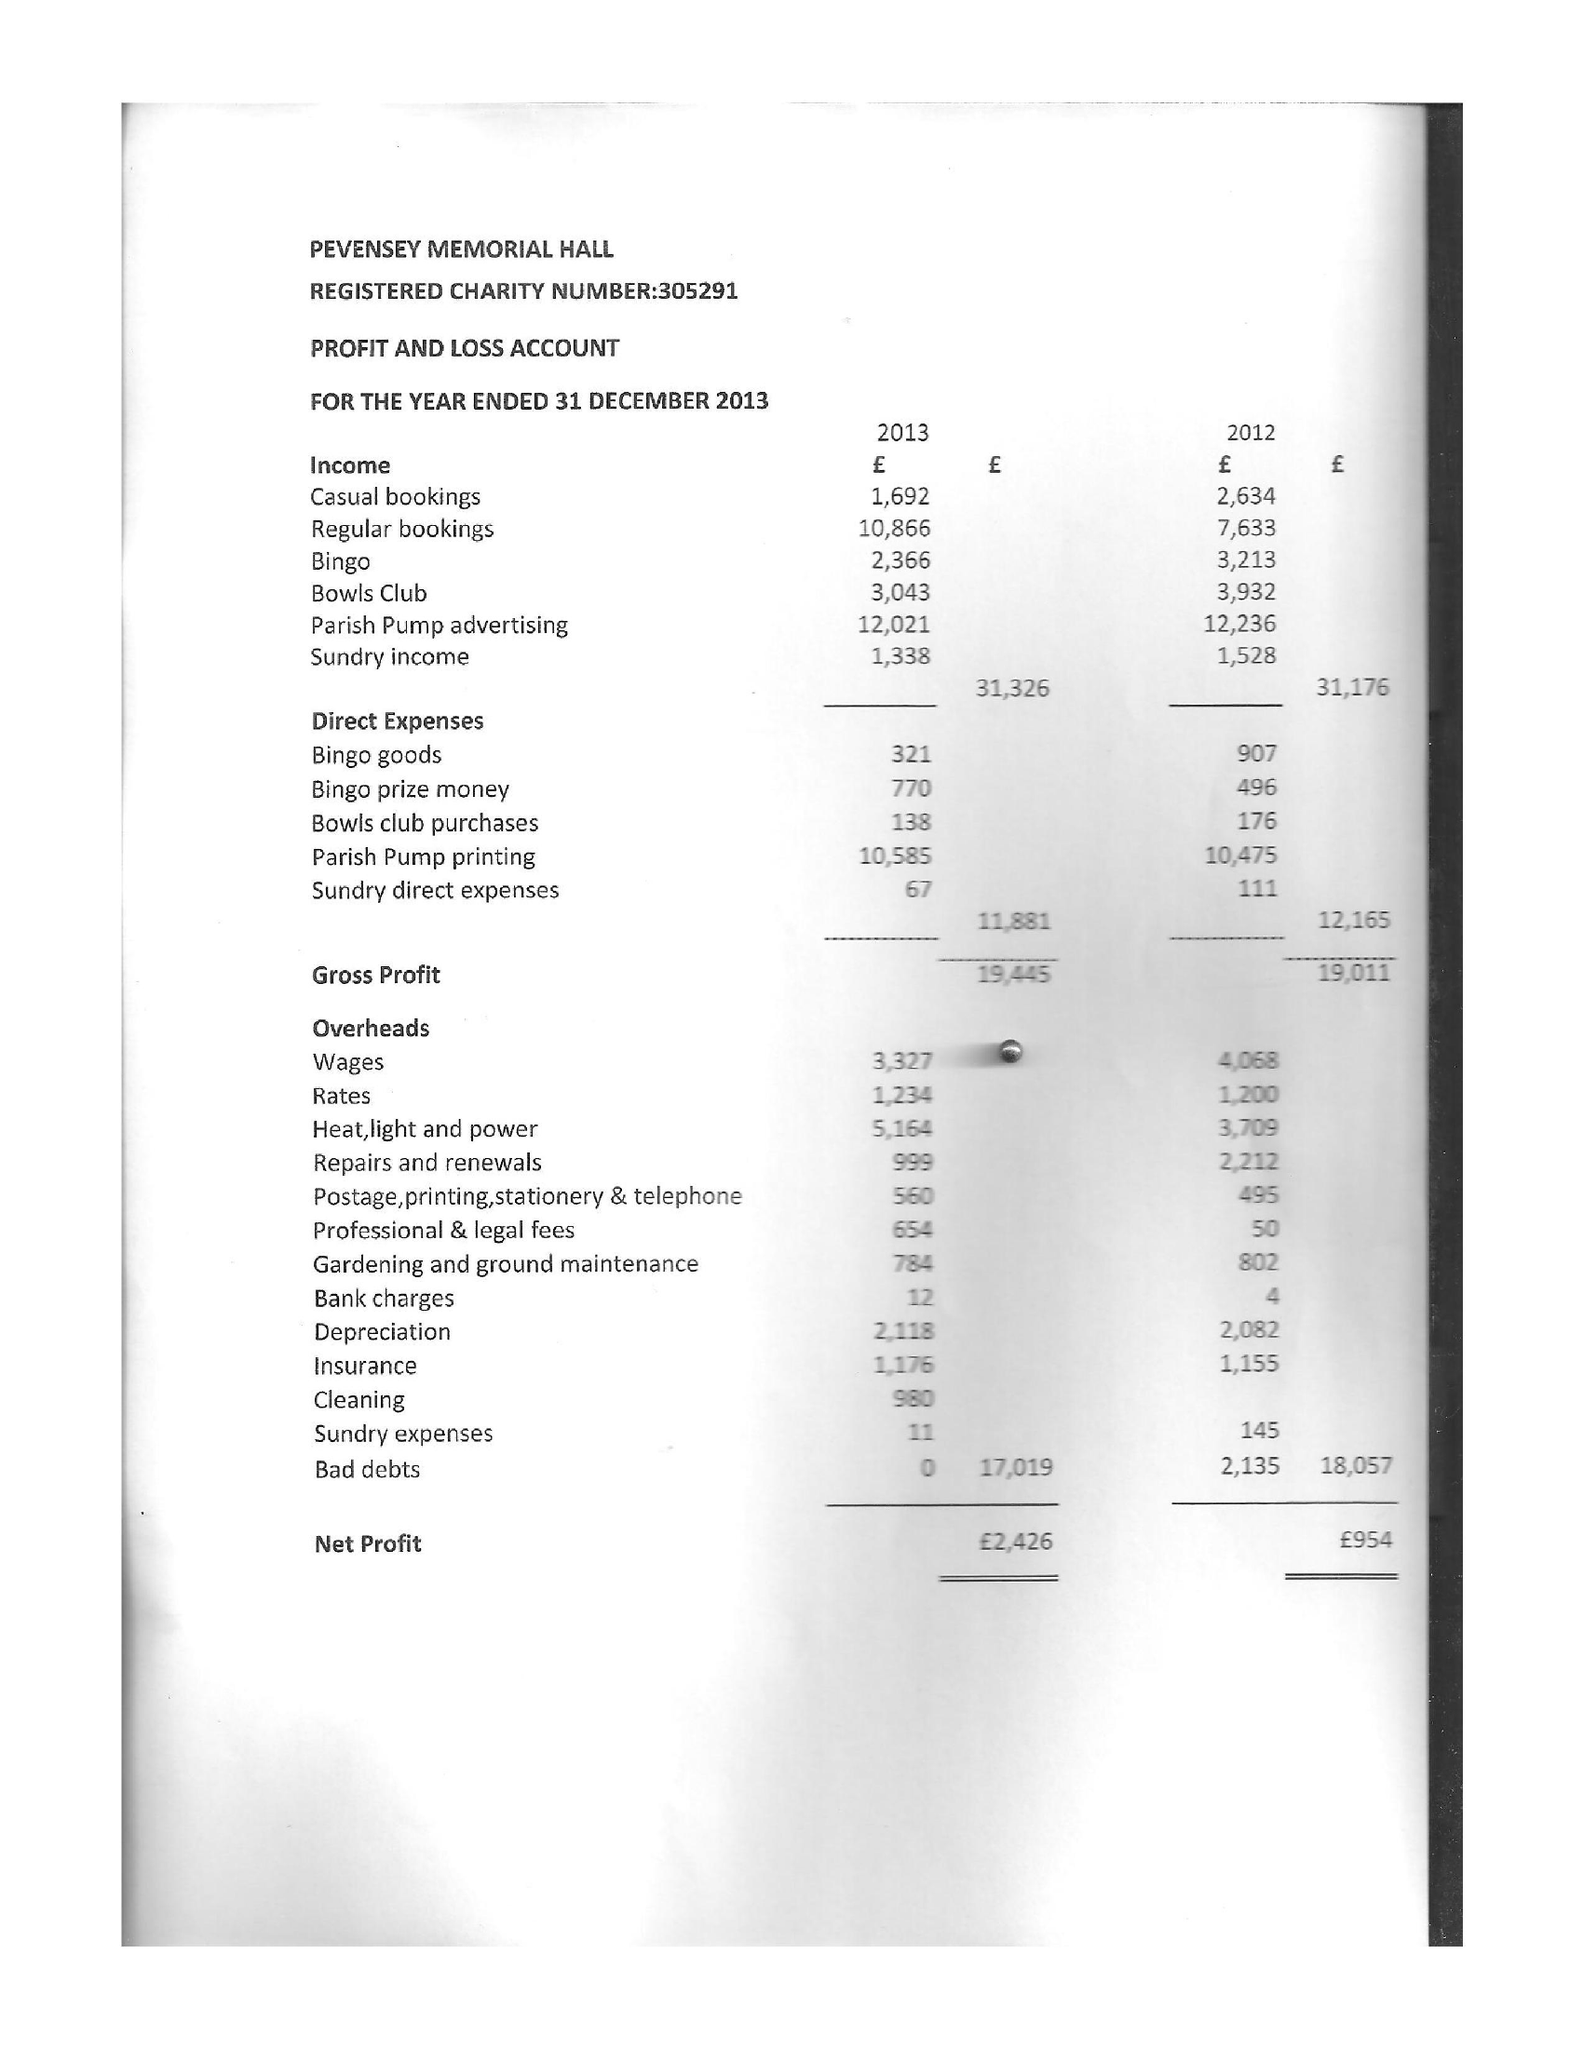What is the value for the address__postcode?
Answer the question using a single word or phrase. BN24 6BH 